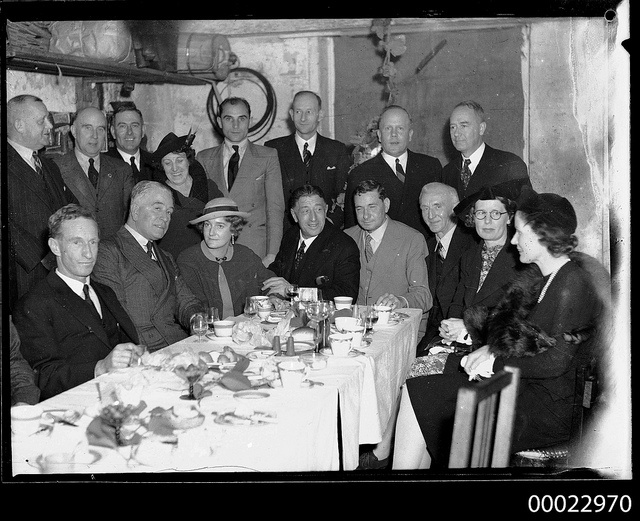Describe the objects in this image and their specific colors. I can see dining table in black, lightgray, darkgray, and dimgray tones, people in black, gray, darkgray, and lightgray tones, people in black, darkgray, lightgray, and gray tones, people in black, darkgray, gray, and lightgray tones, and people in black, gray, darkgray, and lightgray tones in this image. 